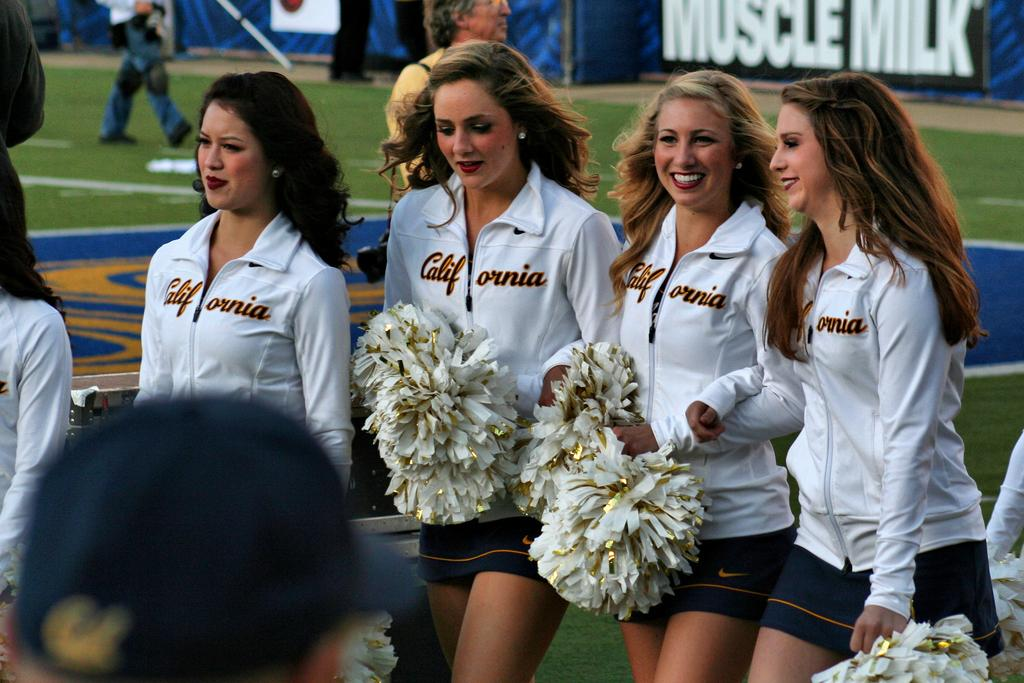Provide a one-sentence caption for the provided image. A group of California cheerleaders stand on a field that is sponsored by Muscle Milk. 